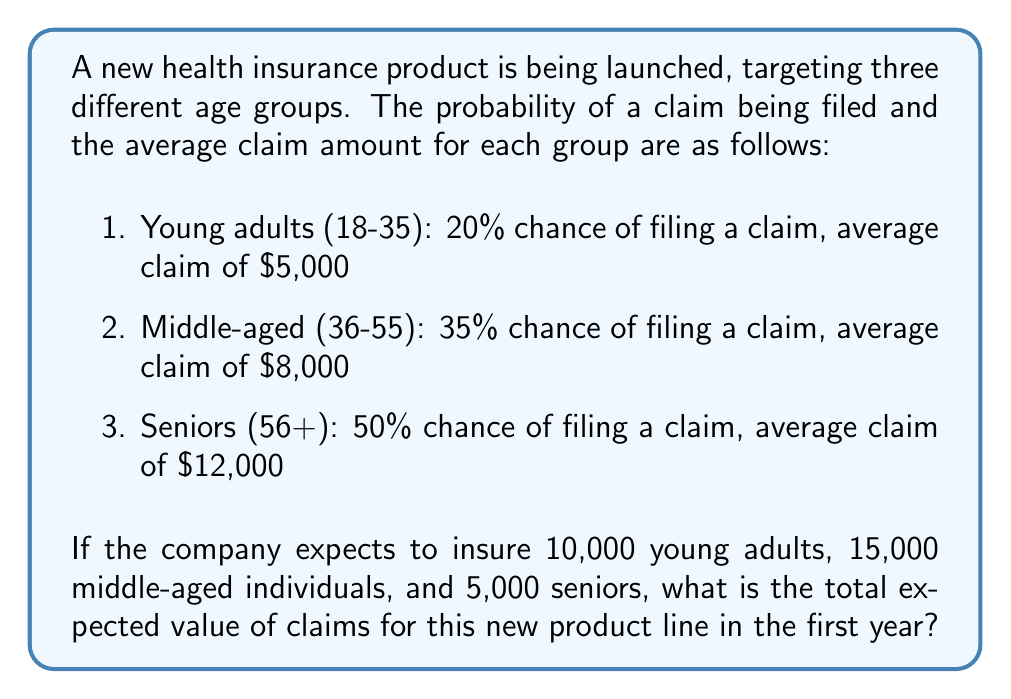Teach me how to tackle this problem. To calculate the total expected value of claims, we need to:

1. Calculate the expected value for each age group
2. Multiply each expected value by the number of insured individuals in that group
3. Sum up the results for all groups

Let's go through this step-by-step:

1. Expected value for each age group:
   a. Young adults: $E_Y = 0.20 \times \$5,000 = \$1,000$
   b. Middle-aged: $E_M = 0.35 \times \$8,000 = \$2,800$
   c. Seniors: $E_S = 0.50 \times \$12,000 = \$6,000$

2. Multiply by the number of insured individuals:
   a. Young adults: $10,000 \times \$1,000 = \$10,000,000$
   b. Middle-aged: $15,000 \times \$2,800 = \$42,000,000$
   c. Seniors: $5,000 \times \$6,000 = \$30,000,000$

3. Sum up the results:
   $$\text{Total Expected Value} = \$10,000,000 + \$42,000,000 + \$30,000,000 = \$82,000,000$$

Therefore, the total expected value of claims for this new product line in the first year is $82,000,000.
Answer: $82,000,000 